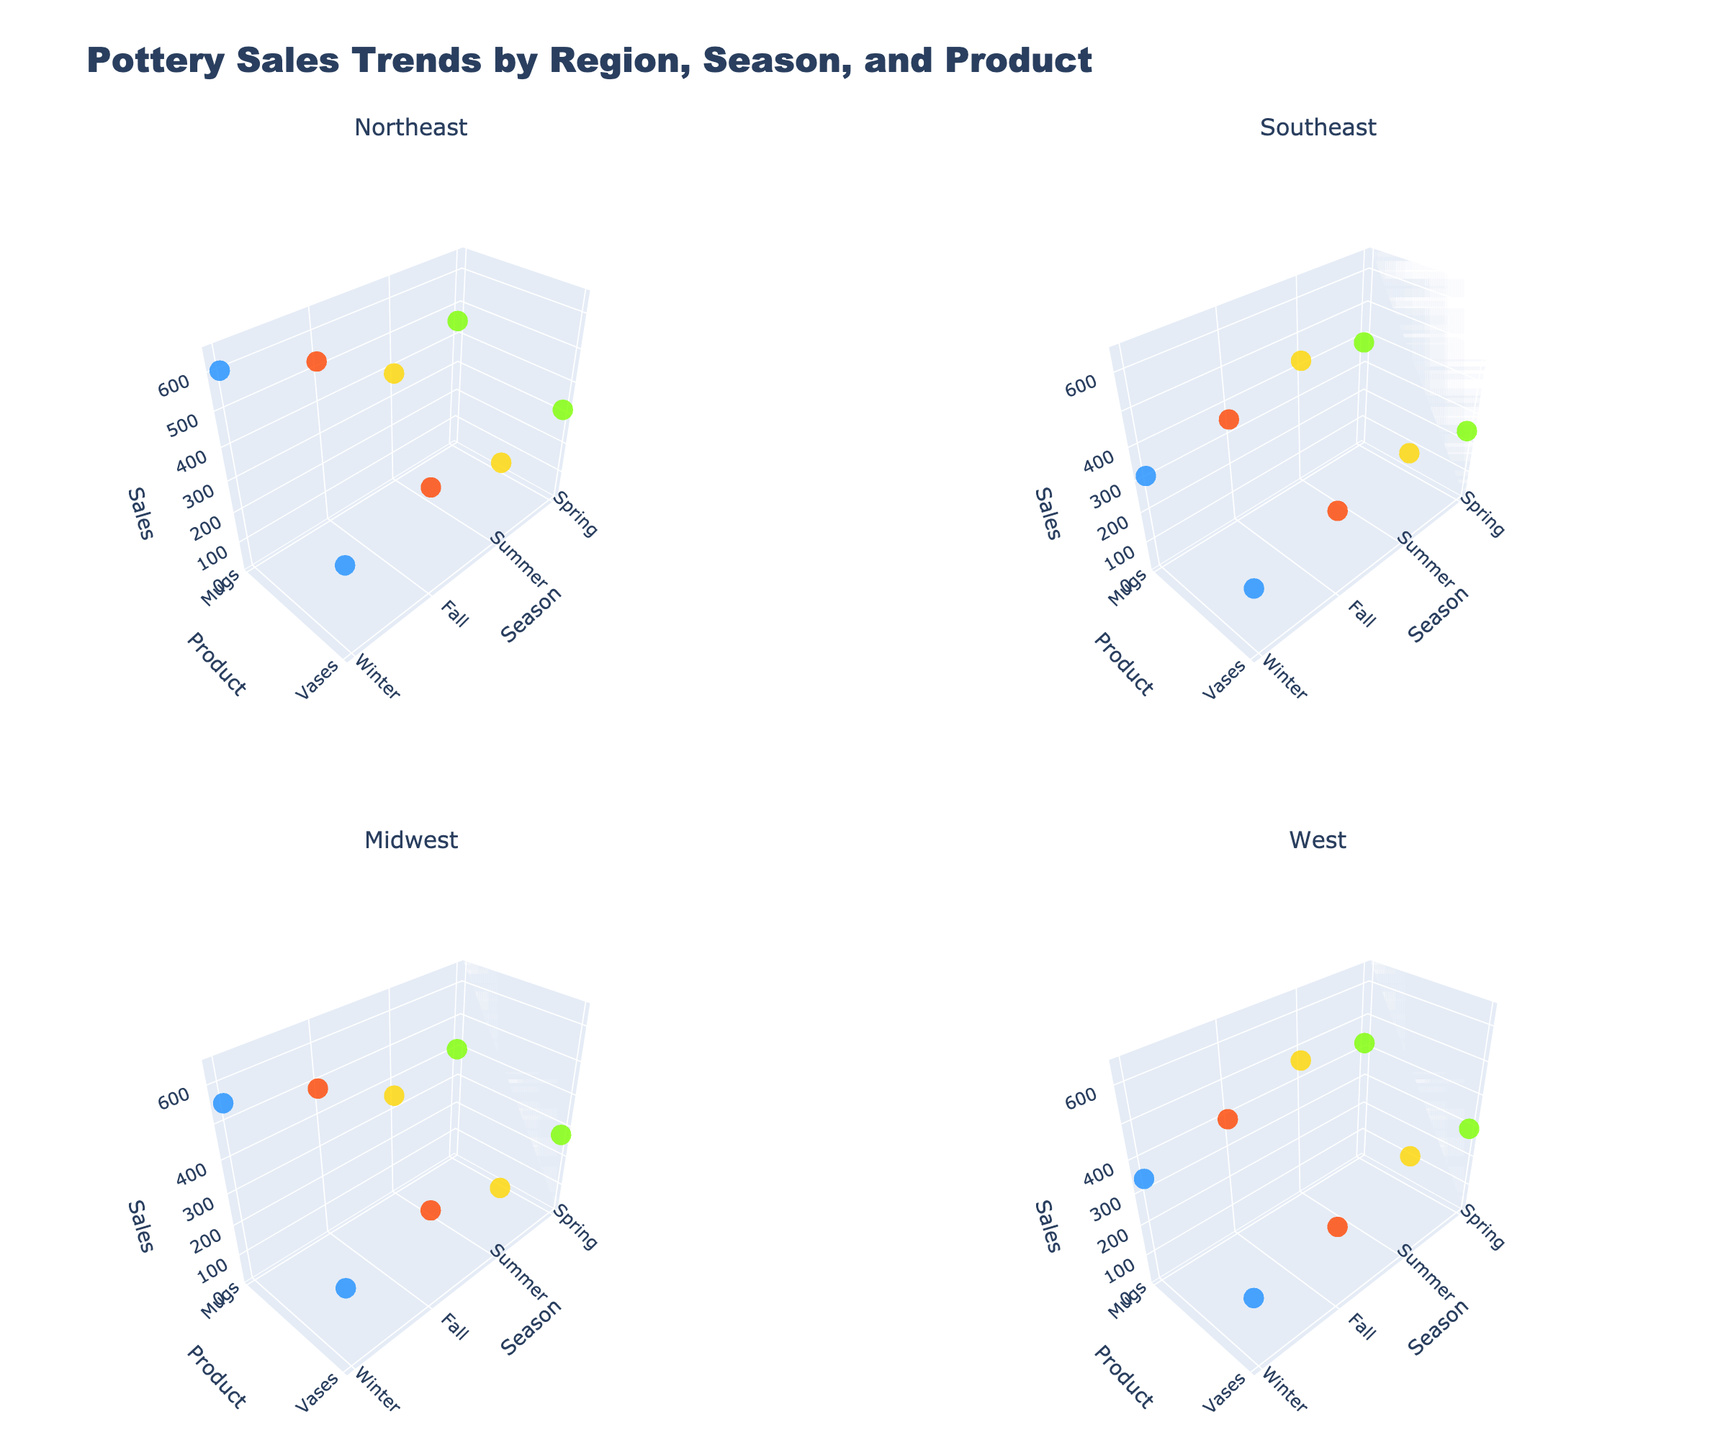What is the title of the figure? The title is usually displayed at the top of the figure and in this case, it mentions the overall subject of the plot.
Answer: Pottery Sales Trends by Region, Season, and Product What are the labels of the x-axis in the subplots? The x-axis represents the seasons. The labels should mention all four seasons.
Answer: Spring, Summer, Fall, Winter Which region has the highest sale of Mugs in Winter? Find the subplot corresponding to each region and check the data points for Winter. Identify the one with the highest Z value.
Answer: Northeast In the Northeast region, which product saw higher sales in Spring: Mugs or Vases? Look at the subplot for the Northeast region and compare the Z values for both products in Spring.
Answer: Mugs How do the sales of Vases in the Midwest during Winter compare to those in Summer? Locate the subplot for the Midwest region and compare the Z values of Vases for Winter and Summer.
Answer: Higher in Winter What is the color representing Summer across all subplots? The colors for the seasons are consistent across the subplots. Identify the color for Summer.
Answer: Yellow Between Northeast and Midwest, which region shows a greater variation in Mugs sales across seasons? Compare the range of Z values for Mugs in both the Northeast and Midwest subplots.
Answer: Northeast What is the pattern for Vases sales in the West region across all seasons? Identify the Z values for Vases in the West region's subplot across all four seasons and describe any trend.
Answer: Decreasing In which region are Spring sales generally closer for Mugs and Vases? Compare the Z values of Mugs and Vases during Spring in each region's subplot and find the region where the values are closest.
Answer: West What is the highest sales number shown in the graph? Scan through all the subplots to identify the maximum Z value for any product in any season.
Answer: 600 